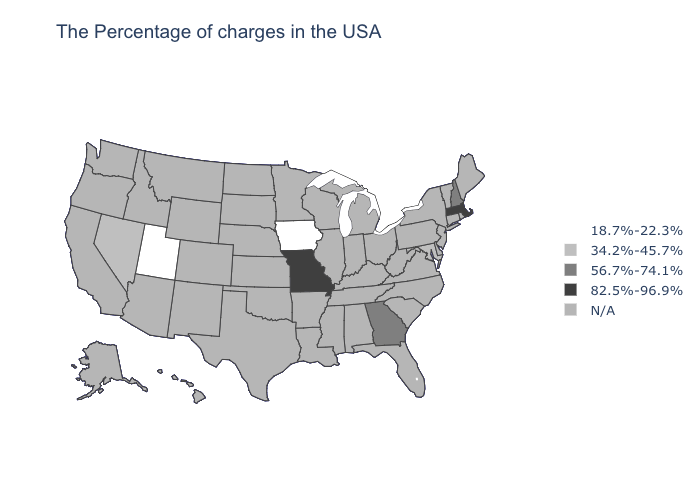What is the value of Maryland?
Concise answer only. 34.2%-45.7%. Among the states that border New Hampshire , which have the lowest value?
Quick response, please. Massachusetts. What is the highest value in the Northeast ?
Give a very brief answer. 82.5%-96.9%. Does the map have missing data?
Write a very short answer. Yes. What is the value of New York?
Answer briefly. N/A. Name the states that have a value in the range N/A?
Answer briefly. Maine, Rhode Island, Vermont, Connecticut, New York, New Jersey, Delaware, Pennsylvania, Virginia, North Carolina, South Carolina, West Virginia, Ohio, Florida, Michigan, Kentucky, Indiana, Alabama, Tennessee, Wisconsin, Illinois, Mississippi, Louisiana, Arkansas, Minnesota, Kansas, Nebraska, Oklahoma, Texas, South Dakota, North Dakota, Wyoming, Colorado, New Mexico, Montana, Arizona, Idaho, California, Washington, Oregon, Alaska, Hawaii. Name the states that have a value in the range 82.5%-96.9%?
Give a very brief answer. Massachusetts, Missouri. Which states hav the highest value in the South?
Keep it brief. Georgia. What is the value of Kentucky?
Quick response, please. N/A. 